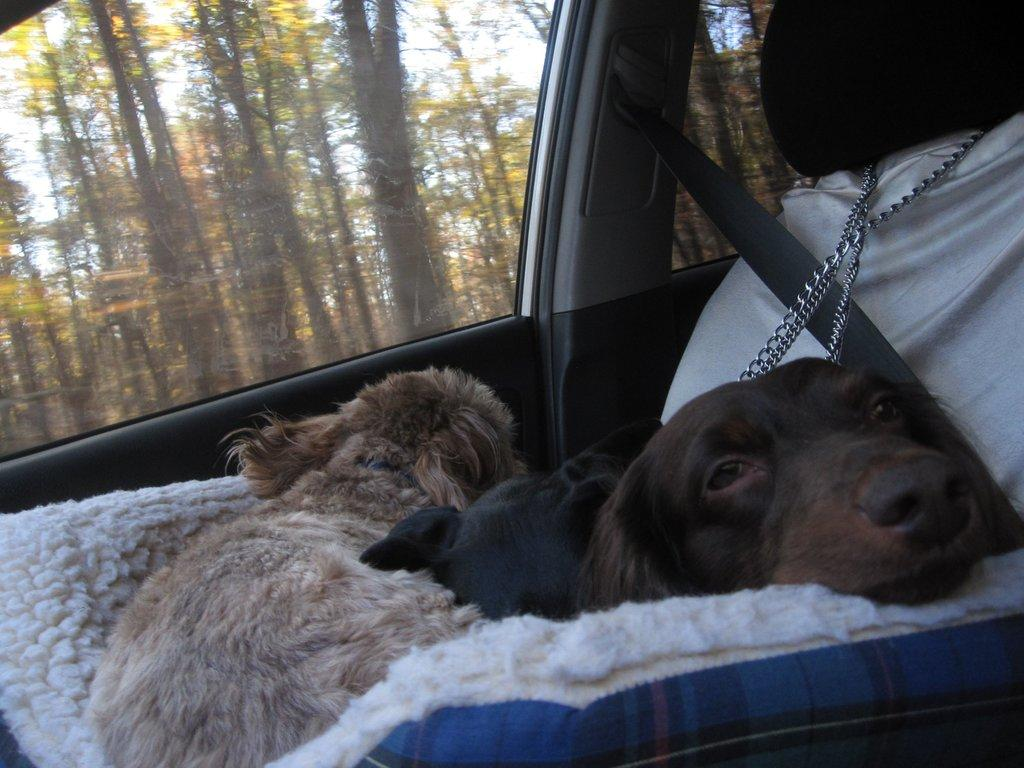Where was the image taken? The image is taken inside a vehicle. What can be seen on the cloth in the image? There are dogs on the cloth. What type of seating is present in the vehicle? There is a seat in the vehicle. What feature allows passengers to see outside the vehicle? There is a glass window in the vehicle. What safety feature is present in the vehicle? There is a seat belt in the vehicle. What can be seen through the window in the image? Trees are visible through the window. What type of yard can be seen through the window in the image? There is no yard visible through the window in the image; only trees can be seen. What type of frame surrounds the image? The provided facts do not mention any frame surrounding the image. 